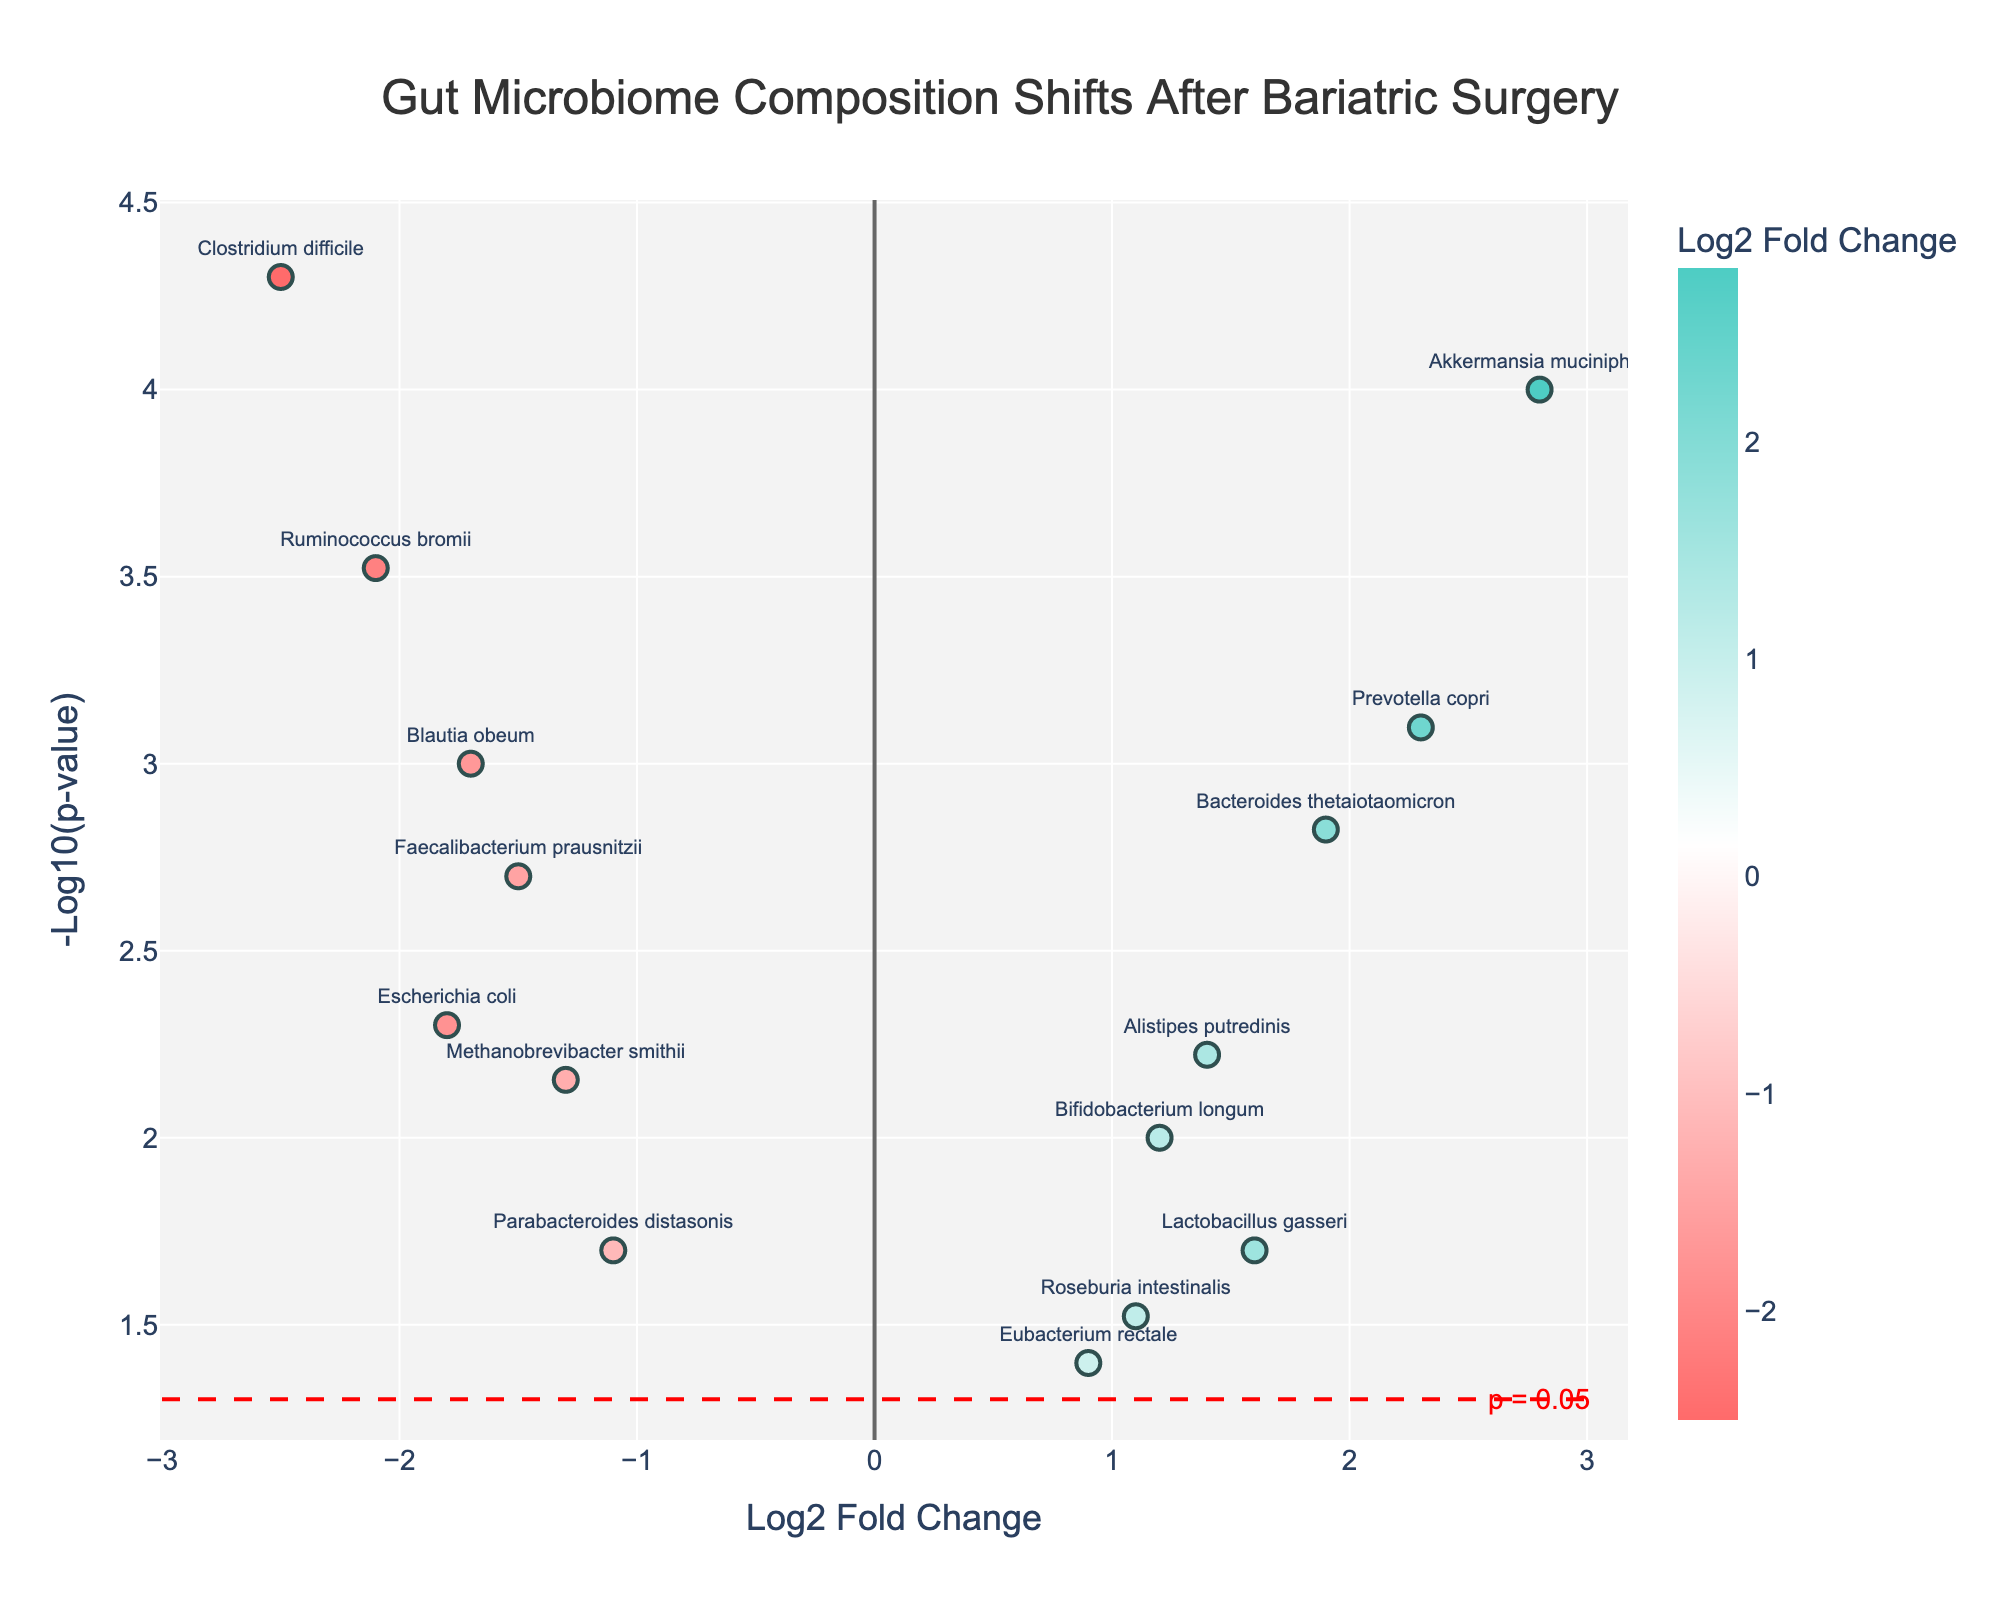How many species have a p-value below 0.01? From the plot, we can see that species with a p-value below 0.01 would be those with a -log10(p-value) higher than 2 (since -log10(0.01) = 2). Identify the species above this line.
Answer: 8 Which species shows the highest increase in abundance after bariatric surgery? The highest increase in abundance is indicated by the species with the highest positive log2FoldChange.
Answer: Akkermansia muciniphila Which species has the most significant decrease in its abundance? The most significant decrease can be found by identifying the species with the lowest (most negative) log2FoldChange value.
Answer: Clostridium difficile How many species showed a significant change (p < 0.05) after the surgery? To find this, count the total number of species plotted above the -log10(p-value) line corresponding to p = 0.05, which is roughly 1.3010 (-log10(0.05)).
Answer: 14 What is the range of log2FoldChange values observed in the plot? Identify the minimum and maximum values on the x-axis (log2FoldChange).
Answer: -2.5 to 2.8 Which species show a decrease in abundance with a p-value less than 0.01? Look for the species on the plot with a negative log2FoldChange and -log10(p-value) greater than 2.0.
Answer: Faecalibacterium prausnitzii, Ruminococcus bromii, Escherichia coli, Clostridium difficile, Blautia obeum What color represents species with a negative log2FoldChange? Negative log2FoldChange values are typically represented by a certain color in the plot. Identify this color from the legend or color bar.
Answer: Red tones Which species had a moderate increase in abundance, not as high as Akkermansia muciniphila but significant (p < 0.05)? Find species with a positive log2FoldChange that is less than 2.8 but still significant and has -log10(p-value) above 1.3010.
Answer: Bacteroides thetaiotaomicron, Prevotella copri 